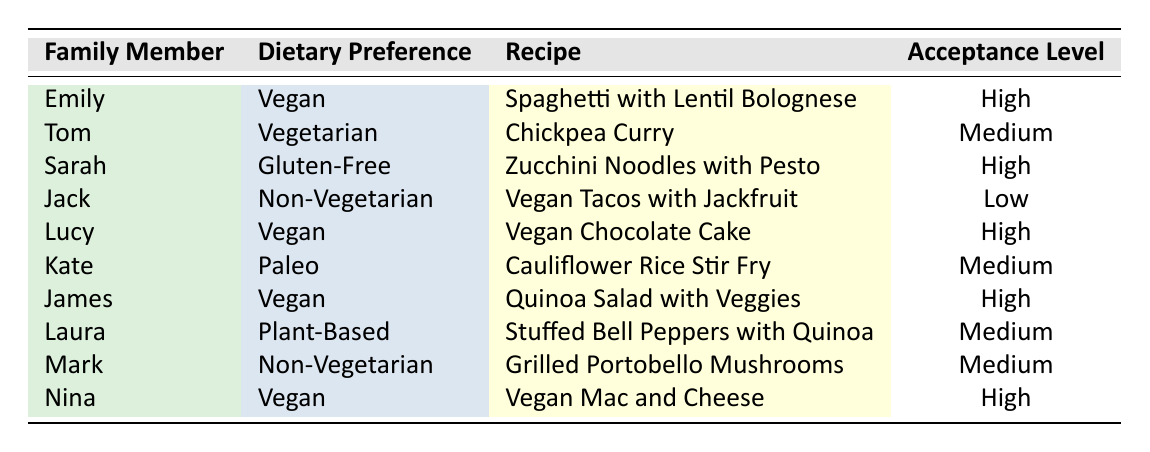What is the acceptance level for Emily's recipe? In the table, under Emily, the recipe listed is "Spaghetti with Lentil Bolognese," which has an acceptance level of "High."
Answer: High Which family member has a low acceptance level for a vegan recipe? The table shows that Jack, who has a dietary preference of "Non-Vegetarian," has a low acceptance level for the vegan recipe "Vegan Tacos with Jackfruit."
Answer: Jack How many family members have a high acceptance level for vegan recipes? Looking at the table, the family members with a high acceptance level for vegan recipes are Emily, Lucy, James, and Nina. This totals to four family members.
Answer: 4 What is the most common dietary preference for the high acceptance level? The high acceptance levels in the table are associated with the dietary preference "Vegan" (Emily, Lucy, James, and Nina). Since there are four vegan recipes and three high acceptance levels among others, "Vegan" is the most common for high acceptance.
Answer: Vegan Is there any recipe that received a medium acceptance level from a family member with a non-vegetarian dietary preference? Yes, Mark has a non-vegetarian dietary preference and shows a medium acceptance level for the recipe "Grilled Portobello Mushrooms," as per the table.
Answer: Yes What percentage of vegan recipes received a high acceptance level? There are five vegan recipes listed: "Spaghetti with Lentil Bolognese," "Vegan Chocolate Cake," "Quinoa Salad with Veggies," "Vegan Mac and Cheese," and "Vegan Tacos with Jackfruit." Out of these, four have high acceptance levels (Emily, Lucy, James, and Nina), making the percentage 4 out of 5, which is 80%.
Answer: 80% Which recipe variation is accepted the least by family members? In the table, the recipe with the lowest acceptance level is "Vegan Tacos with Jackfruit," which Jack, a non-vegetarian, rated as low.
Answer: Vegan Tacos with Jackfruit How many family members are vegetarian or non-vegetarian and have medium acceptance levels? Tom is vegetarian with medium acceptance for "Chickpea Curry," and Mark is non-vegetarian with medium acceptance for "Grilled Portobello Mushrooms." So there are two family members fitting this criterion.
Answer: 2 What is the average acceptance level for all recipes by vegan family members? The vegan family members with their respective acceptance levels are Emily (High), Lucy (High), James (High), and Nina (High). All four have high acceptance levels. Therefore, the average is high since all are the same.
Answer: High What family member accepted a recipe variation the most based on their dietary preference? Looking at the acceptance levels, the family members that accepted recipes the most (high acceptance level) are Emily, Lucy, James, and Nina. Therefore, there isn't a single family member who accepted more than the others since they all accepted at the same level.
Answer: No single family member 